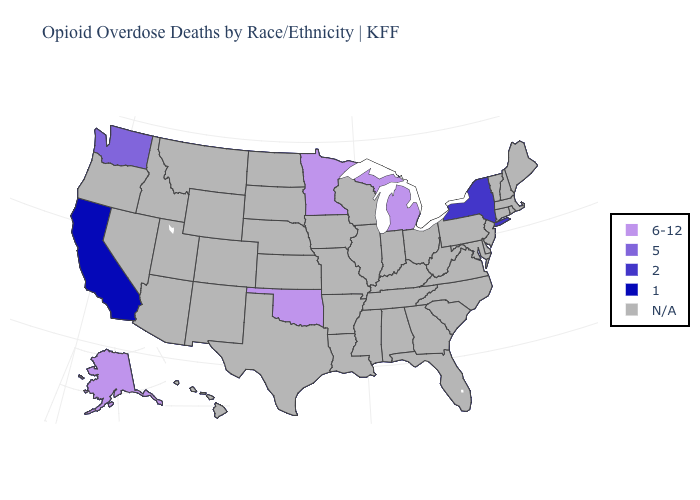What is the value of South Carolina?
Be succinct. N/A. Name the states that have a value in the range N/A?
Answer briefly. Alabama, Arizona, Arkansas, Colorado, Connecticut, Delaware, Florida, Georgia, Hawaii, Idaho, Illinois, Indiana, Iowa, Kansas, Kentucky, Louisiana, Maine, Maryland, Massachusetts, Mississippi, Missouri, Montana, Nebraska, Nevada, New Hampshire, New Jersey, New Mexico, North Carolina, North Dakota, Ohio, Oregon, Pennsylvania, Rhode Island, South Carolina, South Dakota, Tennessee, Texas, Utah, Vermont, Virginia, West Virginia, Wisconsin, Wyoming. Name the states that have a value in the range 6-12?
Give a very brief answer. Alaska, Michigan, Minnesota, Oklahoma. What is the highest value in the Northeast ?
Concise answer only. 2. Name the states that have a value in the range N/A?
Short answer required. Alabama, Arizona, Arkansas, Colorado, Connecticut, Delaware, Florida, Georgia, Hawaii, Idaho, Illinois, Indiana, Iowa, Kansas, Kentucky, Louisiana, Maine, Maryland, Massachusetts, Mississippi, Missouri, Montana, Nebraska, Nevada, New Hampshire, New Jersey, New Mexico, North Carolina, North Dakota, Ohio, Oregon, Pennsylvania, Rhode Island, South Carolina, South Dakota, Tennessee, Texas, Utah, Vermont, Virginia, West Virginia, Wisconsin, Wyoming. What is the value of Colorado?
Concise answer only. N/A. Name the states that have a value in the range N/A?
Give a very brief answer. Alabama, Arizona, Arkansas, Colorado, Connecticut, Delaware, Florida, Georgia, Hawaii, Idaho, Illinois, Indiana, Iowa, Kansas, Kentucky, Louisiana, Maine, Maryland, Massachusetts, Mississippi, Missouri, Montana, Nebraska, Nevada, New Hampshire, New Jersey, New Mexico, North Carolina, North Dakota, Ohio, Oregon, Pennsylvania, Rhode Island, South Carolina, South Dakota, Tennessee, Texas, Utah, Vermont, Virginia, West Virginia, Wisconsin, Wyoming. What is the value of Hawaii?
Keep it brief. N/A. Does the first symbol in the legend represent the smallest category?
Be succinct. No. Among the states that border New Jersey , which have the highest value?
Concise answer only. New York. Which states have the lowest value in the South?
Answer briefly. Oklahoma. 